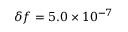Convert formula to latex. <formula><loc_0><loc_0><loc_500><loc_500>\delta f = 5 . 0 \times 1 0 ^ { - 7 }</formula> 